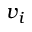Convert formula to latex. <formula><loc_0><loc_0><loc_500><loc_500>v _ { i }</formula> 